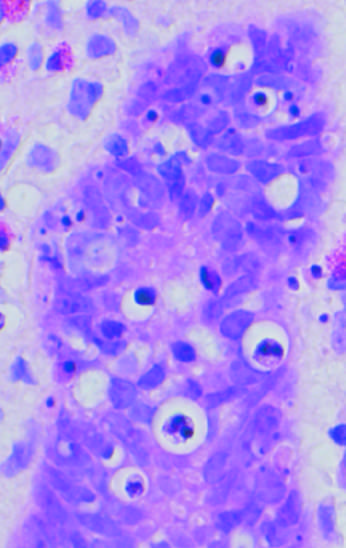what are shown?
Answer the question using a single word or phrase. Apoptotic cells in colonic epithelium 